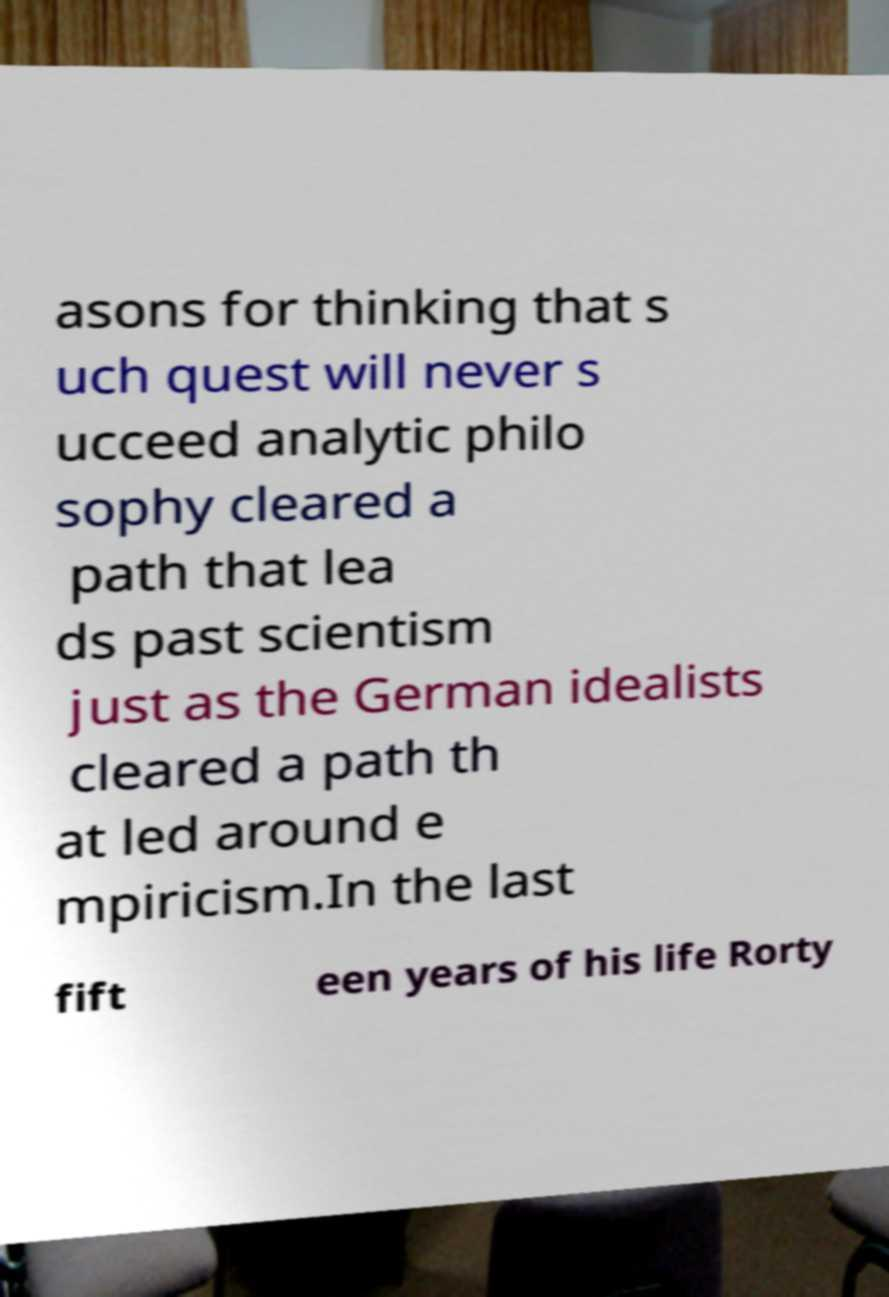Could you extract and type out the text from this image? asons for thinking that s uch quest will never s ucceed analytic philo sophy cleared a path that lea ds past scientism just as the German idealists cleared a path th at led around e mpiricism.In the last fift een years of his life Rorty 